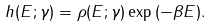<formula> <loc_0><loc_0><loc_500><loc_500>h ( E ; \gamma ) = \rho ( E ; \gamma ) \exp { ( - \beta E ) } .</formula> 